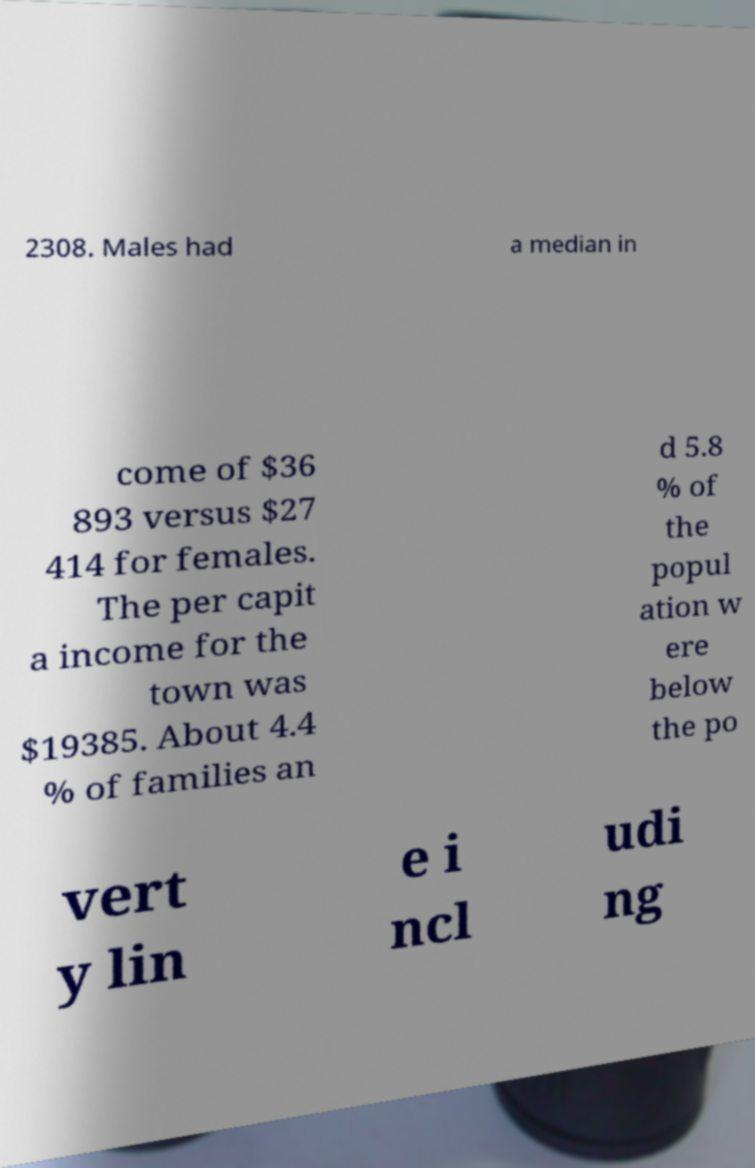Please read and relay the text visible in this image. What does it say? 2308. Males had a median in come of $36 893 versus $27 414 for females. The per capit a income for the town was $19385. About 4.4 % of families an d 5.8 % of the popul ation w ere below the po vert y lin e i ncl udi ng 